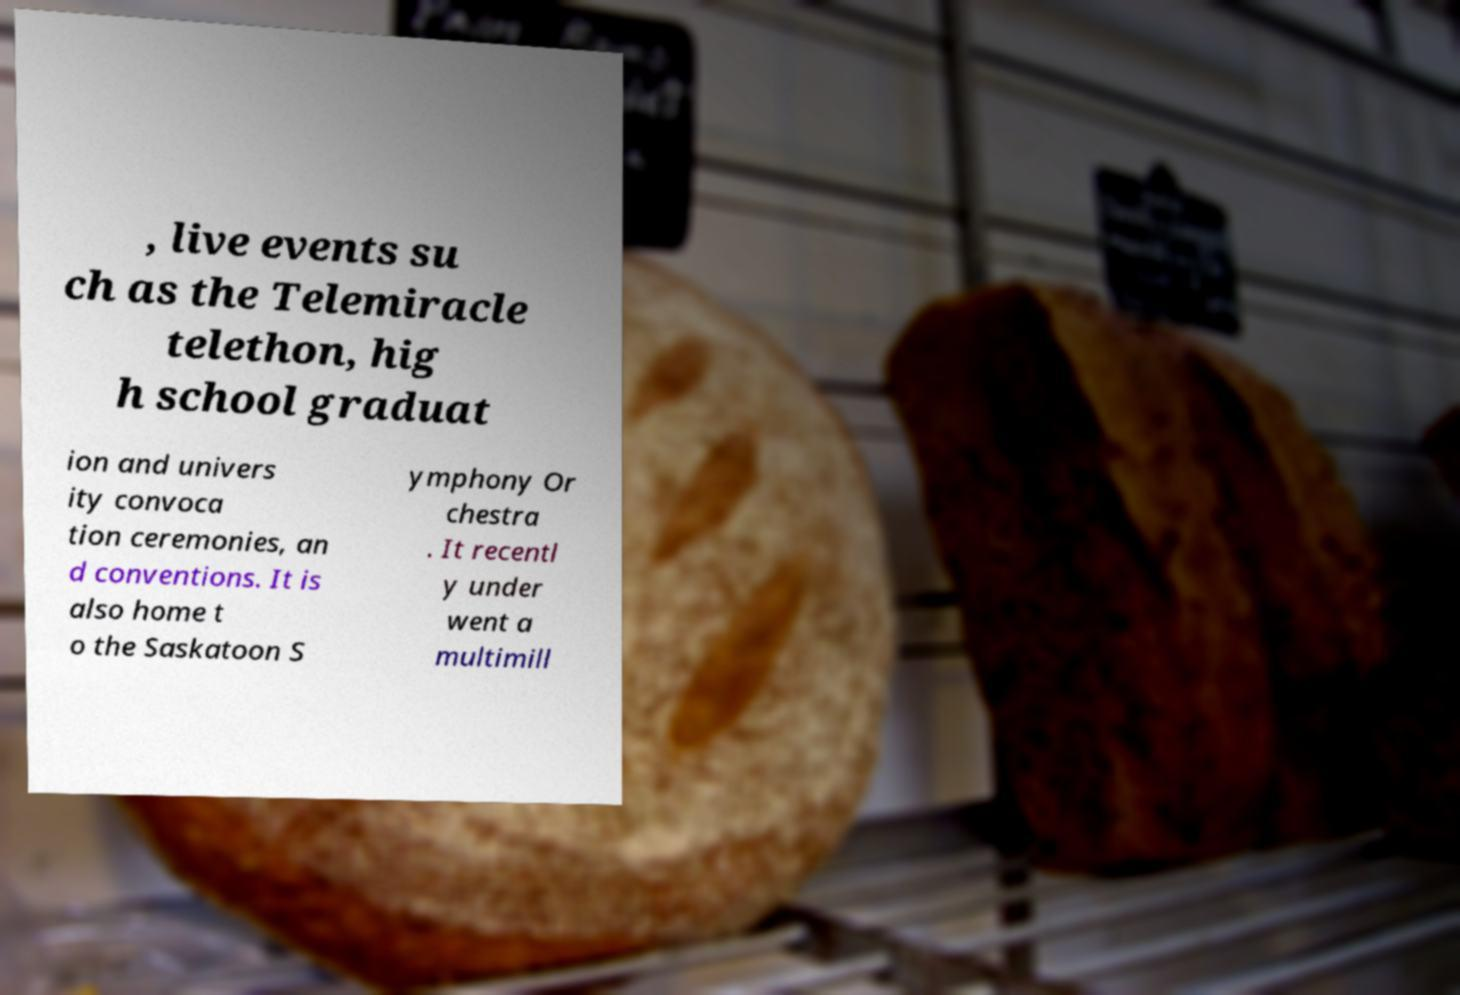Please identify and transcribe the text found in this image. , live events su ch as the Telemiracle telethon, hig h school graduat ion and univers ity convoca tion ceremonies, an d conventions. It is also home t o the Saskatoon S ymphony Or chestra . It recentl y under went a multimill 